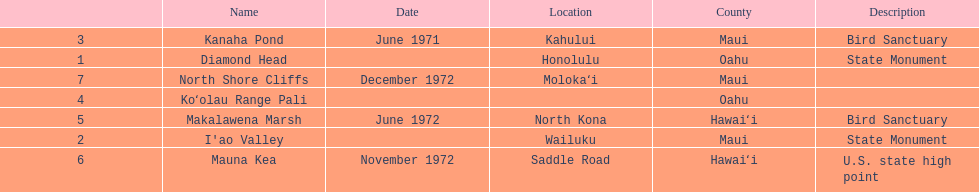What is the total number of state monuments? 2. 